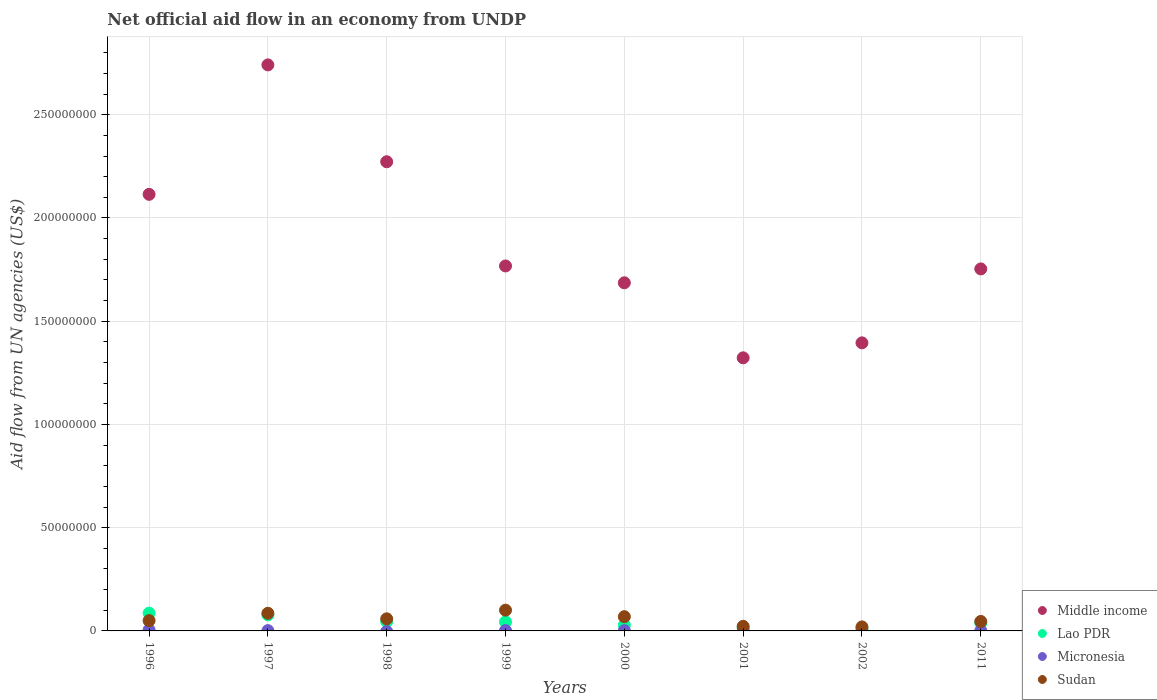Is the number of dotlines equal to the number of legend labels?
Offer a terse response. No. What is the net official aid flow in Lao PDR in 1998?
Give a very brief answer. 4.53e+06. Across all years, what is the maximum net official aid flow in Lao PDR?
Give a very brief answer. 8.61e+06. Across all years, what is the minimum net official aid flow in Middle income?
Your response must be concise. 1.32e+08. What is the total net official aid flow in Lao PDR in the graph?
Give a very brief answer. 3.46e+07. What is the difference between the net official aid flow in Sudan in 1996 and that in 1999?
Provide a short and direct response. -5.05e+06. What is the difference between the net official aid flow in Middle income in 2000 and the net official aid flow in Micronesia in 1996?
Your response must be concise. 1.68e+08. What is the average net official aid flow in Middle income per year?
Make the answer very short. 1.88e+08. In the year 2000, what is the difference between the net official aid flow in Lao PDR and net official aid flow in Middle income?
Your answer should be very brief. -1.66e+08. In how many years, is the net official aid flow in Micronesia greater than 270000000 US$?
Provide a short and direct response. 0. What is the ratio of the net official aid flow in Lao PDR in 2000 to that in 2002?
Make the answer very short. 2.5. What is the difference between the highest and the second highest net official aid flow in Middle income?
Your response must be concise. 4.69e+07. What is the difference between the highest and the lowest net official aid flow in Middle income?
Offer a terse response. 1.42e+08. In how many years, is the net official aid flow in Middle income greater than the average net official aid flow in Middle income taken over all years?
Ensure brevity in your answer.  3. Is it the case that in every year, the sum of the net official aid flow in Middle income and net official aid flow in Lao PDR  is greater than the sum of net official aid flow in Micronesia and net official aid flow in Sudan?
Give a very brief answer. No. Does the net official aid flow in Middle income monotonically increase over the years?
Your answer should be very brief. No. Is the net official aid flow in Middle income strictly greater than the net official aid flow in Micronesia over the years?
Your answer should be very brief. Yes. How many years are there in the graph?
Give a very brief answer. 8. Are the values on the major ticks of Y-axis written in scientific E-notation?
Offer a very short reply. No. Where does the legend appear in the graph?
Keep it short and to the point. Bottom right. How many legend labels are there?
Ensure brevity in your answer.  4. What is the title of the graph?
Your answer should be very brief. Net official aid flow in an economy from UNDP. What is the label or title of the X-axis?
Make the answer very short. Years. What is the label or title of the Y-axis?
Ensure brevity in your answer.  Aid flow from UN agencies (US$). What is the Aid flow from UN agencies (US$) of Middle income in 1996?
Keep it short and to the point. 2.11e+08. What is the Aid flow from UN agencies (US$) of Lao PDR in 1996?
Provide a short and direct response. 8.61e+06. What is the Aid flow from UN agencies (US$) of Micronesia in 1996?
Offer a terse response. 5.10e+05. What is the Aid flow from UN agencies (US$) of Middle income in 1997?
Offer a terse response. 2.74e+08. What is the Aid flow from UN agencies (US$) in Lao PDR in 1997?
Keep it short and to the point. 7.79e+06. What is the Aid flow from UN agencies (US$) in Micronesia in 1997?
Offer a terse response. 1.40e+05. What is the Aid flow from UN agencies (US$) of Sudan in 1997?
Keep it short and to the point. 8.54e+06. What is the Aid flow from UN agencies (US$) of Middle income in 1998?
Offer a terse response. 2.27e+08. What is the Aid flow from UN agencies (US$) in Lao PDR in 1998?
Provide a short and direct response. 4.53e+06. What is the Aid flow from UN agencies (US$) in Sudan in 1998?
Provide a succinct answer. 5.86e+06. What is the Aid flow from UN agencies (US$) of Middle income in 1999?
Your response must be concise. 1.77e+08. What is the Aid flow from UN agencies (US$) of Lao PDR in 1999?
Your response must be concise. 4.37e+06. What is the Aid flow from UN agencies (US$) in Sudan in 1999?
Offer a terse response. 1.00e+07. What is the Aid flow from UN agencies (US$) in Middle income in 2000?
Your answer should be very brief. 1.69e+08. What is the Aid flow from UN agencies (US$) in Lao PDR in 2000?
Offer a terse response. 2.80e+06. What is the Aid flow from UN agencies (US$) of Micronesia in 2000?
Ensure brevity in your answer.  1.50e+05. What is the Aid flow from UN agencies (US$) of Sudan in 2000?
Give a very brief answer. 6.90e+06. What is the Aid flow from UN agencies (US$) in Middle income in 2001?
Give a very brief answer. 1.32e+08. What is the Aid flow from UN agencies (US$) in Lao PDR in 2001?
Make the answer very short. 1.52e+06. What is the Aid flow from UN agencies (US$) of Micronesia in 2001?
Give a very brief answer. 10000. What is the Aid flow from UN agencies (US$) in Sudan in 2001?
Make the answer very short. 2.22e+06. What is the Aid flow from UN agencies (US$) of Middle income in 2002?
Your response must be concise. 1.40e+08. What is the Aid flow from UN agencies (US$) of Lao PDR in 2002?
Your response must be concise. 1.12e+06. What is the Aid flow from UN agencies (US$) of Micronesia in 2002?
Give a very brief answer. 2.00e+04. What is the Aid flow from UN agencies (US$) in Sudan in 2002?
Ensure brevity in your answer.  1.95e+06. What is the Aid flow from UN agencies (US$) in Middle income in 2011?
Your answer should be very brief. 1.75e+08. What is the Aid flow from UN agencies (US$) of Lao PDR in 2011?
Your answer should be very brief. 3.84e+06. What is the Aid flow from UN agencies (US$) of Micronesia in 2011?
Ensure brevity in your answer.  8.00e+04. What is the Aid flow from UN agencies (US$) in Sudan in 2011?
Your answer should be compact. 4.59e+06. Across all years, what is the maximum Aid flow from UN agencies (US$) in Middle income?
Ensure brevity in your answer.  2.74e+08. Across all years, what is the maximum Aid flow from UN agencies (US$) in Lao PDR?
Make the answer very short. 8.61e+06. Across all years, what is the maximum Aid flow from UN agencies (US$) of Micronesia?
Your answer should be very brief. 5.10e+05. Across all years, what is the maximum Aid flow from UN agencies (US$) in Sudan?
Keep it short and to the point. 1.00e+07. Across all years, what is the minimum Aid flow from UN agencies (US$) of Middle income?
Give a very brief answer. 1.32e+08. Across all years, what is the minimum Aid flow from UN agencies (US$) of Lao PDR?
Keep it short and to the point. 1.12e+06. Across all years, what is the minimum Aid flow from UN agencies (US$) of Sudan?
Offer a terse response. 1.95e+06. What is the total Aid flow from UN agencies (US$) of Middle income in the graph?
Your answer should be very brief. 1.51e+09. What is the total Aid flow from UN agencies (US$) in Lao PDR in the graph?
Keep it short and to the point. 3.46e+07. What is the total Aid flow from UN agencies (US$) in Micronesia in the graph?
Offer a terse response. 1.09e+06. What is the total Aid flow from UN agencies (US$) in Sudan in the graph?
Ensure brevity in your answer.  4.51e+07. What is the difference between the Aid flow from UN agencies (US$) of Middle income in 1996 and that in 1997?
Keep it short and to the point. -6.27e+07. What is the difference between the Aid flow from UN agencies (US$) of Lao PDR in 1996 and that in 1997?
Provide a short and direct response. 8.20e+05. What is the difference between the Aid flow from UN agencies (US$) of Sudan in 1996 and that in 1997?
Your answer should be very brief. -3.54e+06. What is the difference between the Aid flow from UN agencies (US$) of Middle income in 1996 and that in 1998?
Ensure brevity in your answer.  -1.58e+07. What is the difference between the Aid flow from UN agencies (US$) in Lao PDR in 1996 and that in 1998?
Keep it short and to the point. 4.08e+06. What is the difference between the Aid flow from UN agencies (US$) in Sudan in 1996 and that in 1998?
Offer a very short reply. -8.60e+05. What is the difference between the Aid flow from UN agencies (US$) in Middle income in 1996 and that in 1999?
Give a very brief answer. 3.47e+07. What is the difference between the Aid flow from UN agencies (US$) of Lao PDR in 1996 and that in 1999?
Offer a very short reply. 4.24e+06. What is the difference between the Aid flow from UN agencies (US$) of Micronesia in 1996 and that in 1999?
Your answer should be compact. 3.30e+05. What is the difference between the Aid flow from UN agencies (US$) of Sudan in 1996 and that in 1999?
Provide a succinct answer. -5.05e+06. What is the difference between the Aid flow from UN agencies (US$) of Middle income in 1996 and that in 2000?
Give a very brief answer. 4.28e+07. What is the difference between the Aid flow from UN agencies (US$) of Lao PDR in 1996 and that in 2000?
Your response must be concise. 5.81e+06. What is the difference between the Aid flow from UN agencies (US$) in Micronesia in 1996 and that in 2000?
Your answer should be very brief. 3.60e+05. What is the difference between the Aid flow from UN agencies (US$) in Sudan in 1996 and that in 2000?
Your response must be concise. -1.90e+06. What is the difference between the Aid flow from UN agencies (US$) in Middle income in 1996 and that in 2001?
Your response must be concise. 7.92e+07. What is the difference between the Aid flow from UN agencies (US$) of Lao PDR in 1996 and that in 2001?
Your answer should be very brief. 7.09e+06. What is the difference between the Aid flow from UN agencies (US$) in Micronesia in 1996 and that in 2001?
Provide a succinct answer. 5.00e+05. What is the difference between the Aid flow from UN agencies (US$) in Sudan in 1996 and that in 2001?
Your answer should be compact. 2.78e+06. What is the difference between the Aid flow from UN agencies (US$) in Middle income in 1996 and that in 2002?
Offer a very short reply. 7.19e+07. What is the difference between the Aid flow from UN agencies (US$) of Lao PDR in 1996 and that in 2002?
Your answer should be very brief. 7.49e+06. What is the difference between the Aid flow from UN agencies (US$) in Micronesia in 1996 and that in 2002?
Your answer should be very brief. 4.90e+05. What is the difference between the Aid flow from UN agencies (US$) in Sudan in 1996 and that in 2002?
Make the answer very short. 3.05e+06. What is the difference between the Aid flow from UN agencies (US$) of Middle income in 1996 and that in 2011?
Provide a short and direct response. 3.61e+07. What is the difference between the Aid flow from UN agencies (US$) in Lao PDR in 1996 and that in 2011?
Give a very brief answer. 4.77e+06. What is the difference between the Aid flow from UN agencies (US$) of Middle income in 1997 and that in 1998?
Make the answer very short. 4.69e+07. What is the difference between the Aid flow from UN agencies (US$) in Lao PDR in 1997 and that in 1998?
Your response must be concise. 3.26e+06. What is the difference between the Aid flow from UN agencies (US$) of Sudan in 1997 and that in 1998?
Provide a succinct answer. 2.68e+06. What is the difference between the Aid flow from UN agencies (US$) in Middle income in 1997 and that in 1999?
Give a very brief answer. 9.74e+07. What is the difference between the Aid flow from UN agencies (US$) in Lao PDR in 1997 and that in 1999?
Offer a terse response. 3.42e+06. What is the difference between the Aid flow from UN agencies (US$) of Sudan in 1997 and that in 1999?
Provide a succinct answer. -1.51e+06. What is the difference between the Aid flow from UN agencies (US$) of Middle income in 1997 and that in 2000?
Offer a terse response. 1.06e+08. What is the difference between the Aid flow from UN agencies (US$) in Lao PDR in 1997 and that in 2000?
Ensure brevity in your answer.  4.99e+06. What is the difference between the Aid flow from UN agencies (US$) in Micronesia in 1997 and that in 2000?
Offer a terse response. -10000. What is the difference between the Aid flow from UN agencies (US$) in Sudan in 1997 and that in 2000?
Keep it short and to the point. 1.64e+06. What is the difference between the Aid flow from UN agencies (US$) in Middle income in 1997 and that in 2001?
Offer a very short reply. 1.42e+08. What is the difference between the Aid flow from UN agencies (US$) in Lao PDR in 1997 and that in 2001?
Your answer should be compact. 6.27e+06. What is the difference between the Aid flow from UN agencies (US$) of Sudan in 1997 and that in 2001?
Ensure brevity in your answer.  6.32e+06. What is the difference between the Aid flow from UN agencies (US$) in Middle income in 1997 and that in 2002?
Keep it short and to the point. 1.35e+08. What is the difference between the Aid flow from UN agencies (US$) of Lao PDR in 1997 and that in 2002?
Ensure brevity in your answer.  6.67e+06. What is the difference between the Aid flow from UN agencies (US$) in Sudan in 1997 and that in 2002?
Your answer should be compact. 6.59e+06. What is the difference between the Aid flow from UN agencies (US$) of Middle income in 1997 and that in 2011?
Your answer should be compact. 9.88e+07. What is the difference between the Aid flow from UN agencies (US$) in Lao PDR in 1997 and that in 2011?
Ensure brevity in your answer.  3.95e+06. What is the difference between the Aid flow from UN agencies (US$) in Micronesia in 1997 and that in 2011?
Your response must be concise. 6.00e+04. What is the difference between the Aid flow from UN agencies (US$) in Sudan in 1997 and that in 2011?
Offer a terse response. 3.95e+06. What is the difference between the Aid flow from UN agencies (US$) in Middle income in 1998 and that in 1999?
Offer a terse response. 5.05e+07. What is the difference between the Aid flow from UN agencies (US$) of Sudan in 1998 and that in 1999?
Provide a short and direct response. -4.19e+06. What is the difference between the Aid flow from UN agencies (US$) in Middle income in 1998 and that in 2000?
Make the answer very short. 5.86e+07. What is the difference between the Aid flow from UN agencies (US$) of Lao PDR in 1998 and that in 2000?
Make the answer very short. 1.73e+06. What is the difference between the Aid flow from UN agencies (US$) in Sudan in 1998 and that in 2000?
Your answer should be compact. -1.04e+06. What is the difference between the Aid flow from UN agencies (US$) in Middle income in 1998 and that in 2001?
Provide a succinct answer. 9.50e+07. What is the difference between the Aid flow from UN agencies (US$) in Lao PDR in 1998 and that in 2001?
Your answer should be compact. 3.01e+06. What is the difference between the Aid flow from UN agencies (US$) of Sudan in 1998 and that in 2001?
Offer a terse response. 3.64e+06. What is the difference between the Aid flow from UN agencies (US$) in Middle income in 1998 and that in 2002?
Offer a terse response. 8.77e+07. What is the difference between the Aid flow from UN agencies (US$) in Lao PDR in 1998 and that in 2002?
Give a very brief answer. 3.41e+06. What is the difference between the Aid flow from UN agencies (US$) in Sudan in 1998 and that in 2002?
Your response must be concise. 3.91e+06. What is the difference between the Aid flow from UN agencies (US$) in Middle income in 1998 and that in 2011?
Your response must be concise. 5.19e+07. What is the difference between the Aid flow from UN agencies (US$) of Lao PDR in 1998 and that in 2011?
Offer a terse response. 6.90e+05. What is the difference between the Aid flow from UN agencies (US$) in Sudan in 1998 and that in 2011?
Provide a succinct answer. 1.27e+06. What is the difference between the Aid flow from UN agencies (US$) of Middle income in 1999 and that in 2000?
Make the answer very short. 8.16e+06. What is the difference between the Aid flow from UN agencies (US$) of Lao PDR in 1999 and that in 2000?
Ensure brevity in your answer.  1.57e+06. What is the difference between the Aid flow from UN agencies (US$) of Micronesia in 1999 and that in 2000?
Ensure brevity in your answer.  3.00e+04. What is the difference between the Aid flow from UN agencies (US$) in Sudan in 1999 and that in 2000?
Ensure brevity in your answer.  3.15e+06. What is the difference between the Aid flow from UN agencies (US$) of Middle income in 1999 and that in 2001?
Your answer should be very brief. 4.45e+07. What is the difference between the Aid flow from UN agencies (US$) in Lao PDR in 1999 and that in 2001?
Provide a short and direct response. 2.85e+06. What is the difference between the Aid flow from UN agencies (US$) in Micronesia in 1999 and that in 2001?
Provide a short and direct response. 1.70e+05. What is the difference between the Aid flow from UN agencies (US$) in Sudan in 1999 and that in 2001?
Offer a terse response. 7.83e+06. What is the difference between the Aid flow from UN agencies (US$) in Middle income in 1999 and that in 2002?
Your answer should be compact. 3.72e+07. What is the difference between the Aid flow from UN agencies (US$) of Lao PDR in 1999 and that in 2002?
Your answer should be very brief. 3.25e+06. What is the difference between the Aid flow from UN agencies (US$) in Micronesia in 1999 and that in 2002?
Provide a succinct answer. 1.60e+05. What is the difference between the Aid flow from UN agencies (US$) in Sudan in 1999 and that in 2002?
Ensure brevity in your answer.  8.10e+06. What is the difference between the Aid flow from UN agencies (US$) of Middle income in 1999 and that in 2011?
Provide a succinct answer. 1.43e+06. What is the difference between the Aid flow from UN agencies (US$) in Lao PDR in 1999 and that in 2011?
Offer a very short reply. 5.30e+05. What is the difference between the Aid flow from UN agencies (US$) in Sudan in 1999 and that in 2011?
Provide a succinct answer. 5.46e+06. What is the difference between the Aid flow from UN agencies (US$) of Middle income in 2000 and that in 2001?
Offer a very short reply. 3.63e+07. What is the difference between the Aid flow from UN agencies (US$) in Lao PDR in 2000 and that in 2001?
Your answer should be very brief. 1.28e+06. What is the difference between the Aid flow from UN agencies (US$) of Sudan in 2000 and that in 2001?
Keep it short and to the point. 4.68e+06. What is the difference between the Aid flow from UN agencies (US$) in Middle income in 2000 and that in 2002?
Offer a terse response. 2.91e+07. What is the difference between the Aid flow from UN agencies (US$) of Lao PDR in 2000 and that in 2002?
Provide a short and direct response. 1.68e+06. What is the difference between the Aid flow from UN agencies (US$) of Micronesia in 2000 and that in 2002?
Provide a succinct answer. 1.30e+05. What is the difference between the Aid flow from UN agencies (US$) of Sudan in 2000 and that in 2002?
Provide a succinct answer. 4.95e+06. What is the difference between the Aid flow from UN agencies (US$) of Middle income in 2000 and that in 2011?
Offer a very short reply. -6.73e+06. What is the difference between the Aid flow from UN agencies (US$) in Lao PDR in 2000 and that in 2011?
Ensure brevity in your answer.  -1.04e+06. What is the difference between the Aid flow from UN agencies (US$) of Sudan in 2000 and that in 2011?
Give a very brief answer. 2.31e+06. What is the difference between the Aid flow from UN agencies (US$) of Middle income in 2001 and that in 2002?
Give a very brief answer. -7.25e+06. What is the difference between the Aid flow from UN agencies (US$) of Lao PDR in 2001 and that in 2002?
Your answer should be compact. 4.00e+05. What is the difference between the Aid flow from UN agencies (US$) in Middle income in 2001 and that in 2011?
Your response must be concise. -4.31e+07. What is the difference between the Aid flow from UN agencies (US$) in Lao PDR in 2001 and that in 2011?
Ensure brevity in your answer.  -2.32e+06. What is the difference between the Aid flow from UN agencies (US$) of Micronesia in 2001 and that in 2011?
Your answer should be compact. -7.00e+04. What is the difference between the Aid flow from UN agencies (US$) of Sudan in 2001 and that in 2011?
Keep it short and to the point. -2.37e+06. What is the difference between the Aid flow from UN agencies (US$) in Middle income in 2002 and that in 2011?
Ensure brevity in your answer.  -3.58e+07. What is the difference between the Aid flow from UN agencies (US$) of Lao PDR in 2002 and that in 2011?
Give a very brief answer. -2.72e+06. What is the difference between the Aid flow from UN agencies (US$) in Sudan in 2002 and that in 2011?
Offer a very short reply. -2.64e+06. What is the difference between the Aid flow from UN agencies (US$) of Middle income in 1996 and the Aid flow from UN agencies (US$) of Lao PDR in 1997?
Offer a very short reply. 2.04e+08. What is the difference between the Aid flow from UN agencies (US$) in Middle income in 1996 and the Aid flow from UN agencies (US$) in Micronesia in 1997?
Your answer should be compact. 2.11e+08. What is the difference between the Aid flow from UN agencies (US$) of Middle income in 1996 and the Aid flow from UN agencies (US$) of Sudan in 1997?
Your response must be concise. 2.03e+08. What is the difference between the Aid flow from UN agencies (US$) in Lao PDR in 1996 and the Aid flow from UN agencies (US$) in Micronesia in 1997?
Give a very brief answer. 8.47e+06. What is the difference between the Aid flow from UN agencies (US$) in Micronesia in 1996 and the Aid flow from UN agencies (US$) in Sudan in 1997?
Offer a terse response. -8.03e+06. What is the difference between the Aid flow from UN agencies (US$) in Middle income in 1996 and the Aid flow from UN agencies (US$) in Lao PDR in 1998?
Ensure brevity in your answer.  2.07e+08. What is the difference between the Aid flow from UN agencies (US$) of Middle income in 1996 and the Aid flow from UN agencies (US$) of Sudan in 1998?
Your answer should be very brief. 2.06e+08. What is the difference between the Aid flow from UN agencies (US$) of Lao PDR in 1996 and the Aid flow from UN agencies (US$) of Sudan in 1998?
Keep it short and to the point. 2.75e+06. What is the difference between the Aid flow from UN agencies (US$) in Micronesia in 1996 and the Aid flow from UN agencies (US$) in Sudan in 1998?
Your response must be concise. -5.35e+06. What is the difference between the Aid flow from UN agencies (US$) of Middle income in 1996 and the Aid flow from UN agencies (US$) of Lao PDR in 1999?
Keep it short and to the point. 2.07e+08. What is the difference between the Aid flow from UN agencies (US$) of Middle income in 1996 and the Aid flow from UN agencies (US$) of Micronesia in 1999?
Your response must be concise. 2.11e+08. What is the difference between the Aid flow from UN agencies (US$) in Middle income in 1996 and the Aid flow from UN agencies (US$) in Sudan in 1999?
Your answer should be very brief. 2.01e+08. What is the difference between the Aid flow from UN agencies (US$) in Lao PDR in 1996 and the Aid flow from UN agencies (US$) in Micronesia in 1999?
Make the answer very short. 8.43e+06. What is the difference between the Aid flow from UN agencies (US$) of Lao PDR in 1996 and the Aid flow from UN agencies (US$) of Sudan in 1999?
Your answer should be compact. -1.44e+06. What is the difference between the Aid flow from UN agencies (US$) in Micronesia in 1996 and the Aid flow from UN agencies (US$) in Sudan in 1999?
Make the answer very short. -9.54e+06. What is the difference between the Aid flow from UN agencies (US$) of Middle income in 1996 and the Aid flow from UN agencies (US$) of Lao PDR in 2000?
Your answer should be very brief. 2.09e+08. What is the difference between the Aid flow from UN agencies (US$) of Middle income in 1996 and the Aid flow from UN agencies (US$) of Micronesia in 2000?
Your response must be concise. 2.11e+08. What is the difference between the Aid flow from UN agencies (US$) of Middle income in 1996 and the Aid flow from UN agencies (US$) of Sudan in 2000?
Offer a very short reply. 2.05e+08. What is the difference between the Aid flow from UN agencies (US$) in Lao PDR in 1996 and the Aid flow from UN agencies (US$) in Micronesia in 2000?
Offer a very short reply. 8.46e+06. What is the difference between the Aid flow from UN agencies (US$) of Lao PDR in 1996 and the Aid flow from UN agencies (US$) of Sudan in 2000?
Provide a succinct answer. 1.71e+06. What is the difference between the Aid flow from UN agencies (US$) of Micronesia in 1996 and the Aid flow from UN agencies (US$) of Sudan in 2000?
Offer a very short reply. -6.39e+06. What is the difference between the Aid flow from UN agencies (US$) in Middle income in 1996 and the Aid flow from UN agencies (US$) in Lao PDR in 2001?
Provide a short and direct response. 2.10e+08. What is the difference between the Aid flow from UN agencies (US$) in Middle income in 1996 and the Aid flow from UN agencies (US$) in Micronesia in 2001?
Your answer should be very brief. 2.11e+08. What is the difference between the Aid flow from UN agencies (US$) in Middle income in 1996 and the Aid flow from UN agencies (US$) in Sudan in 2001?
Give a very brief answer. 2.09e+08. What is the difference between the Aid flow from UN agencies (US$) of Lao PDR in 1996 and the Aid flow from UN agencies (US$) of Micronesia in 2001?
Provide a short and direct response. 8.60e+06. What is the difference between the Aid flow from UN agencies (US$) of Lao PDR in 1996 and the Aid flow from UN agencies (US$) of Sudan in 2001?
Your answer should be compact. 6.39e+06. What is the difference between the Aid flow from UN agencies (US$) of Micronesia in 1996 and the Aid flow from UN agencies (US$) of Sudan in 2001?
Your answer should be very brief. -1.71e+06. What is the difference between the Aid flow from UN agencies (US$) in Middle income in 1996 and the Aid flow from UN agencies (US$) in Lao PDR in 2002?
Your response must be concise. 2.10e+08. What is the difference between the Aid flow from UN agencies (US$) of Middle income in 1996 and the Aid flow from UN agencies (US$) of Micronesia in 2002?
Ensure brevity in your answer.  2.11e+08. What is the difference between the Aid flow from UN agencies (US$) in Middle income in 1996 and the Aid flow from UN agencies (US$) in Sudan in 2002?
Ensure brevity in your answer.  2.09e+08. What is the difference between the Aid flow from UN agencies (US$) of Lao PDR in 1996 and the Aid flow from UN agencies (US$) of Micronesia in 2002?
Offer a terse response. 8.59e+06. What is the difference between the Aid flow from UN agencies (US$) in Lao PDR in 1996 and the Aid flow from UN agencies (US$) in Sudan in 2002?
Your answer should be very brief. 6.66e+06. What is the difference between the Aid flow from UN agencies (US$) of Micronesia in 1996 and the Aid flow from UN agencies (US$) of Sudan in 2002?
Offer a very short reply. -1.44e+06. What is the difference between the Aid flow from UN agencies (US$) in Middle income in 1996 and the Aid flow from UN agencies (US$) in Lao PDR in 2011?
Make the answer very short. 2.08e+08. What is the difference between the Aid flow from UN agencies (US$) in Middle income in 1996 and the Aid flow from UN agencies (US$) in Micronesia in 2011?
Offer a terse response. 2.11e+08. What is the difference between the Aid flow from UN agencies (US$) in Middle income in 1996 and the Aid flow from UN agencies (US$) in Sudan in 2011?
Make the answer very short. 2.07e+08. What is the difference between the Aid flow from UN agencies (US$) in Lao PDR in 1996 and the Aid flow from UN agencies (US$) in Micronesia in 2011?
Your answer should be compact. 8.53e+06. What is the difference between the Aid flow from UN agencies (US$) of Lao PDR in 1996 and the Aid flow from UN agencies (US$) of Sudan in 2011?
Offer a very short reply. 4.02e+06. What is the difference between the Aid flow from UN agencies (US$) of Micronesia in 1996 and the Aid flow from UN agencies (US$) of Sudan in 2011?
Your answer should be very brief. -4.08e+06. What is the difference between the Aid flow from UN agencies (US$) of Middle income in 1997 and the Aid flow from UN agencies (US$) of Lao PDR in 1998?
Make the answer very short. 2.70e+08. What is the difference between the Aid flow from UN agencies (US$) in Middle income in 1997 and the Aid flow from UN agencies (US$) in Sudan in 1998?
Your answer should be very brief. 2.68e+08. What is the difference between the Aid flow from UN agencies (US$) in Lao PDR in 1997 and the Aid flow from UN agencies (US$) in Sudan in 1998?
Your answer should be compact. 1.93e+06. What is the difference between the Aid flow from UN agencies (US$) in Micronesia in 1997 and the Aid flow from UN agencies (US$) in Sudan in 1998?
Your answer should be very brief. -5.72e+06. What is the difference between the Aid flow from UN agencies (US$) of Middle income in 1997 and the Aid flow from UN agencies (US$) of Lao PDR in 1999?
Provide a succinct answer. 2.70e+08. What is the difference between the Aid flow from UN agencies (US$) in Middle income in 1997 and the Aid flow from UN agencies (US$) in Micronesia in 1999?
Provide a succinct answer. 2.74e+08. What is the difference between the Aid flow from UN agencies (US$) in Middle income in 1997 and the Aid flow from UN agencies (US$) in Sudan in 1999?
Keep it short and to the point. 2.64e+08. What is the difference between the Aid flow from UN agencies (US$) of Lao PDR in 1997 and the Aid flow from UN agencies (US$) of Micronesia in 1999?
Provide a short and direct response. 7.61e+06. What is the difference between the Aid flow from UN agencies (US$) in Lao PDR in 1997 and the Aid flow from UN agencies (US$) in Sudan in 1999?
Give a very brief answer. -2.26e+06. What is the difference between the Aid flow from UN agencies (US$) in Micronesia in 1997 and the Aid flow from UN agencies (US$) in Sudan in 1999?
Make the answer very short. -9.91e+06. What is the difference between the Aid flow from UN agencies (US$) in Middle income in 1997 and the Aid flow from UN agencies (US$) in Lao PDR in 2000?
Provide a short and direct response. 2.71e+08. What is the difference between the Aid flow from UN agencies (US$) of Middle income in 1997 and the Aid flow from UN agencies (US$) of Micronesia in 2000?
Offer a very short reply. 2.74e+08. What is the difference between the Aid flow from UN agencies (US$) of Middle income in 1997 and the Aid flow from UN agencies (US$) of Sudan in 2000?
Offer a terse response. 2.67e+08. What is the difference between the Aid flow from UN agencies (US$) of Lao PDR in 1997 and the Aid flow from UN agencies (US$) of Micronesia in 2000?
Ensure brevity in your answer.  7.64e+06. What is the difference between the Aid flow from UN agencies (US$) of Lao PDR in 1997 and the Aid flow from UN agencies (US$) of Sudan in 2000?
Keep it short and to the point. 8.90e+05. What is the difference between the Aid flow from UN agencies (US$) of Micronesia in 1997 and the Aid flow from UN agencies (US$) of Sudan in 2000?
Offer a very short reply. -6.76e+06. What is the difference between the Aid flow from UN agencies (US$) in Middle income in 1997 and the Aid flow from UN agencies (US$) in Lao PDR in 2001?
Provide a short and direct response. 2.73e+08. What is the difference between the Aid flow from UN agencies (US$) of Middle income in 1997 and the Aid flow from UN agencies (US$) of Micronesia in 2001?
Offer a very short reply. 2.74e+08. What is the difference between the Aid flow from UN agencies (US$) of Middle income in 1997 and the Aid flow from UN agencies (US$) of Sudan in 2001?
Provide a succinct answer. 2.72e+08. What is the difference between the Aid flow from UN agencies (US$) in Lao PDR in 1997 and the Aid flow from UN agencies (US$) in Micronesia in 2001?
Keep it short and to the point. 7.78e+06. What is the difference between the Aid flow from UN agencies (US$) in Lao PDR in 1997 and the Aid flow from UN agencies (US$) in Sudan in 2001?
Provide a succinct answer. 5.57e+06. What is the difference between the Aid flow from UN agencies (US$) in Micronesia in 1997 and the Aid flow from UN agencies (US$) in Sudan in 2001?
Provide a succinct answer. -2.08e+06. What is the difference between the Aid flow from UN agencies (US$) in Middle income in 1997 and the Aid flow from UN agencies (US$) in Lao PDR in 2002?
Keep it short and to the point. 2.73e+08. What is the difference between the Aid flow from UN agencies (US$) of Middle income in 1997 and the Aid flow from UN agencies (US$) of Micronesia in 2002?
Keep it short and to the point. 2.74e+08. What is the difference between the Aid flow from UN agencies (US$) in Middle income in 1997 and the Aid flow from UN agencies (US$) in Sudan in 2002?
Your response must be concise. 2.72e+08. What is the difference between the Aid flow from UN agencies (US$) in Lao PDR in 1997 and the Aid flow from UN agencies (US$) in Micronesia in 2002?
Your answer should be very brief. 7.77e+06. What is the difference between the Aid flow from UN agencies (US$) of Lao PDR in 1997 and the Aid flow from UN agencies (US$) of Sudan in 2002?
Offer a terse response. 5.84e+06. What is the difference between the Aid flow from UN agencies (US$) of Micronesia in 1997 and the Aid flow from UN agencies (US$) of Sudan in 2002?
Your answer should be very brief. -1.81e+06. What is the difference between the Aid flow from UN agencies (US$) of Middle income in 1997 and the Aid flow from UN agencies (US$) of Lao PDR in 2011?
Ensure brevity in your answer.  2.70e+08. What is the difference between the Aid flow from UN agencies (US$) of Middle income in 1997 and the Aid flow from UN agencies (US$) of Micronesia in 2011?
Ensure brevity in your answer.  2.74e+08. What is the difference between the Aid flow from UN agencies (US$) of Middle income in 1997 and the Aid flow from UN agencies (US$) of Sudan in 2011?
Give a very brief answer. 2.70e+08. What is the difference between the Aid flow from UN agencies (US$) in Lao PDR in 1997 and the Aid flow from UN agencies (US$) in Micronesia in 2011?
Offer a terse response. 7.71e+06. What is the difference between the Aid flow from UN agencies (US$) of Lao PDR in 1997 and the Aid flow from UN agencies (US$) of Sudan in 2011?
Offer a terse response. 3.20e+06. What is the difference between the Aid flow from UN agencies (US$) in Micronesia in 1997 and the Aid flow from UN agencies (US$) in Sudan in 2011?
Your answer should be very brief. -4.45e+06. What is the difference between the Aid flow from UN agencies (US$) in Middle income in 1998 and the Aid flow from UN agencies (US$) in Lao PDR in 1999?
Offer a terse response. 2.23e+08. What is the difference between the Aid flow from UN agencies (US$) in Middle income in 1998 and the Aid flow from UN agencies (US$) in Micronesia in 1999?
Your answer should be very brief. 2.27e+08. What is the difference between the Aid flow from UN agencies (US$) in Middle income in 1998 and the Aid flow from UN agencies (US$) in Sudan in 1999?
Ensure brevity in your answer.  2.17e+08. What is the difference between the Aid flow from UN agencies (US$) in Lao PDR in 1998 and the Aid flow from UN agencies (US$) in Micronesia in 1999?
Your answer should be very brief. 4.35e+06. What is the difference between the Aid flow from UN agencies (US$) of Lao PDR in 1998 and the Aid flow from UN agencies (US$) of Sudan in 1999?
Provide a succinct answer. -5.52e+06. What is the difference between the Aid flow from UN agencies (US$) of Middle income in 1998 and the Aid flow from UN agencies (US$) of Lao PDR in 2000?
Provide a short and direct response. 2.24e+08. What is the difference between the Aid flow from UN agencies (US$) of Middle income in 1998 and the Aid flow from UN agencies (US$) of Micronesia in 2000?
Ensure brevity in your answer.  2.27e+08. What is the difference between the Aid flow from UN agencies (US$) in Middle income in 1998 and the Aid flow from UN agencies (US$) in Sudan in 2000?
Your answer should be compact. 2.20e+08. What is the difference between the Aid flow from UN agencies (US$) in Lao PDR in 1998 and the Aid flow from UN agencies (US$) in Micronesia in 2000?
Offer a very short reply. 4.38e+06. What is the difference between the Aid flow from UN agencies (US$) in Lao PDR in 1998 and the Aid flow from UN agencies (US$) in Sudan in 2000?
Provide a short and direct response. -2.37e+06. What is the difference between the Aid flow from UN agencies (US$) of Middle income in 1998 and the Aid flow from UN agencies (US$) of Lao PDR in 2001?
Your response must be concise. 2.26e+08. What is the difference between the Aid flow from UN agencies (US$) of Middle income in 1998 and the Aid flow from UN agencies (US$) of Micronesia in 2001?
Provide a succinct answer. 2.27e+08. What is the difference between the Aid flow from UN agencies (US$) of Middle income in 1998 and the Aid flow from UN agencies (US$) of Sudan in 2001?
Give a very brief answer. 2.25e+08. What is the difference between the Aid flow from UN agencies (US$) in Lao PDR in 1998 and the Aid flow from UN agencies (US$) in Micronesia in 2001?
Your answer should be compact. 4.52e+06. What is the difference between the Aid flow from UN agencies (US$) in Lao PDR in 1998 and the Aid flow from UN agencies (US$) in Sudan in 2001?
Your response must be concise. 2.31e+06. What is the difference between the Aid flow from UN agencies (US$) of Middle income in 1998 and the Aid flow from UN agencies (US$) of Lao PDR in 2002?
Provide a short and direct response. 2.26e+08. What is the difference between the Aid flow from UN agencies (US$) of Middle income in 1998 and the Aid flow from UN agencies (US$) of Micronesia in 2002?
Provide a short and direct response. 2.27e+08. What is the difference between the Aid flow from UN agencies (US$) of Middle income in 1998 and the Aid flow from UN agencies (US$) of Sudan in 2002?
Provide a short and direct response. 2.25e+08. What is the difference between the Aid flow from UN agencies (US$) in Lao PDR in 1998 and the Aid flow from UN agencies (US$) in Micronesia in 2002?
Keep it short and to the point. 4.51e+06. What is the difference between the Aid flow from UN agencies (US$) in Lao PDR in 1998 and the Aid flow from UN agencies (US$) in Sudan in 2002?
Offer a very short reply. 2.58e+06. What is the difference between the Aid flow from UN agencies (US$) in Middle income in 1998 and the Aid flow from UN agencies (US$) in Lao PDR in 2011?
Offer a terse response. 2.23e+08. What is the difference between the Aid flow from UN agencies (US$) in Middle income in 1998 and the Aid flow from UN agencies (US$) in Micronesia in 2011?
Your answer should be very brief. 2.27e+08. What is the difference between the Aid flow from UN agencies (US$) of Middle income in 1998 and the Aid flow from UN agencies (US$) of Sudan in 2011?
Keep it short and to the point. 2.23e+08. What is the difference between the Aid flow from UN agencies (US$) of Lao PDR in 1998 and the Aid flow from UN agencies (US$) of Micronesia in 2011?
Offer a very short reply. 4.45e+06. What is the difference between the Aid flow from UN agencies (US$) in Lao PDR in 1998 and the Aid flow from UN agencies (US$) in Sudan in 2011?
Make the answer very short. -6.00e+04. What is the difference between the Aid flow from UN agencies (US$) of Middle income in 1999 and the Aid flow from UN agencies (US$) of Lao PDR in 2000?
Your answer should be very brief. 1.74e+08. What is the difference between the Aid flow from UN agencies (US$) of Middle income in 1999 and the Aid flow from UN agencies (US$) of Micronesia in 2000?
Make the answer very short. 1.77e+08. What is the difference between the Aid flow from UN agencies (US$) of Middle income in 1999 and the Aid flow from UN agencies (US$) of Sudan in 2000?
Provide a succinct answer. 1.70e+08. What is the difference between the Aid flow from UN agencies (US$) of Lao PDR in 1999 and the Aid flow from UN agencies (US$) of Micronesia in 2000?
Your answer should be very brief. 4.22e+06. What is the difference between the Aid flow from UN agencies (US$) of Lao PDR in 1999 and the Aid flow from UN agencies (US$) of Sudan in 2000?
Offer a terse response. -2.53e+06. What is the difference between the Aid flow from UN agencies (US$) in Micronesia in 1999 and the Aid flow from UN agencies (US$) in Sudan in 2000?
Keep it short and to the point. -6.72e+06. What is the difference between the Aid flow from UN agencies (US$) in Middle income in 1999 and the Aid flow from UN agencies (US$) in Lao PDR in 2001?
Your answer should be very brief. 1.75e+08. What is the difference between the Aid flow from UN agencies (US$) of Middle income in 1999 and the Aid flow from UN agencies (US$) of Micronesia in 2001?
Your answer should be compact. 1.77e+08. What is the difference between the Aid flow from UN agencies (US$) of Middle income in 1999 and the Aid flow from UN agencies (US$) of Sudan in 2001?
Your answer should be very brief. 1.75e+08. What is the difference between the Aid flow from UN agencies (US$) of Lao PDR in 1999 and the Aid flow from UN agencies (US$) of Micronesia in 2001?
Provide a succinct answer. 4.36e+06. What is the difference between the Aid flow from UN agencies (US$) in Lao PDR in 1999 and the Aid flow from UN agencies (US$) in Sudan in 2001?
Your answer should be compact. 2.15e+06. What is the difference between the Aid flow from UN agencies (US$) of Micronesia in 1999 and the Aid flow from UN agencies (US$) of Sudan in 2001?
Ensure brevity in your answer.  -2.04e+06. What is the difference between the Aid flow from UN agencies (US$) in Middle income in 1999 and the Aid flow from UN agencies (US$) in Lao PDR in 2002?
Your answer should be very brief. 1.76e+08. What is the difference between the Aid flow from UN agencies (US$) in Middle income in 1999 and the Aid flow from UN agencies (US$) in Micronesia in 2002?
Your answer should be very brief. 1.77e+08. What is the difference between the Aid flow from UN agencies (US$) in Middle income in 1999 and the Aid flow from UN agencies (US$) in Sudan in 2002?
Give a very brief answer. 1.75e+08. What is the difference between the Aid flow from UN agencies (US$) of Lao PDR in 1999 and the Aid flow from UN agencies (US$) of Micronesia in 2002?
Your response must be concise. 4.35e+06. What is the difference between the Aid flow from UN agencies (US$) in Lao PDR in 1999 and the Aid flow from UN agencies (US$) in Sudan in 2002?
Offer a very short reply. 2.42e+06. What is the difference between the Aid flow from UN agencies (US$) in Micronesia in 1999 and the Aid flow from UN agencies (US$) in Sudan in 2002?
Provide a succinct answer. -1.77e+06. What is the difference between the Aid flow from UN agencies (US$) of Middle income in 1999 and the Aid flow from UN agencies (US$) of Lao PDR in 2011?
Provide a short and direct response. 1.73e+08. What is the difference between the Aid flow from UN agencies (US$) of Middle income in 1999 and the Aid flow from UN agencies (US$) of Micronesia in 2011?
Provide a short and direct response. 1.77e+08. What is the difference between the Aid flow from UN agencies (US$) of Middle income in 1999 and the Aid flow from UN agencies (US$) of Sudan in 2011?
Your answer should be very brief. 1.72e+08. What is the difference between the Aid flow from UN agencies (US$) in Lao PDR in 1999 and the Aid flow from UN agencies (US$) in Micronesia in 2011?
Ensure brevity in your answer.  4.29e+06. What is the difference between the Aid flow from UN agencies (US$) of Lao PDR in 1999 and the Aid flow from UN agencies (US$) of Sudan in 2011?
Provide a succinct answer. -2.20e+05. What is the difference between the Aid flow from UN agencies (US$) of Micronesia in 1999 and the Aid flow from UN agencies (US$) of Sudan in 2011?
Provide a short and direct response. -4.41e+06. What is the difference between the Aid flow from UN agencies (US$) of Middle income in 2000 and the Aid flow from UN agencies (US$) of Lao PDR in 2001?
Provide a succinct answer. 1.67e+08. What is the difference between the Aid flow from UN agencies (US$) of Middle income in 2000 and the Aid flow from UN agencies (US$) of Micronesia in 2001?
Provide a short and direct response. 1.69e+08. What is the difference between the Aid flow from UN agencies (US$) in Middle income in 2000 and the Aid flow from UN agencies (US$) in Sudan in 2001?
Provide a succinct answer. 1.66e+08. What is the difference between the Aid flow from UN agencies (US$) of Lao PDR in 2000 and the Aid flow from UN agencies (US$) of Micronesia in 2001?
Your answer should be very brief. 2.79e+06. What is the difference between the Aid flow from UN agencies (US$) of Lao PDR in 2000 and the Aid flow from UN agencies (US$) of Sudan in 2001?
Give a very brief answer. 5.80e+05. What is the difference between the Aid flow from UN agencies (US$) of Micronesia in 2000 and the Aid flow from UN agencies (US$) of Sudan in 2001?
Give a very brief answer. -2.07e+06. What is the difference between the Aid flow from UN agencies (US$) of Middle income in 2000 and the Aid flow from UN agencies (US$) of Lao PDR in 2002?
Offer a very short reply. 1.67e+08. What is the difference between the Aid flow from UN agencies (US$) of Middle income in 2000 and the Aid flow from UN agencies (US$) of Micronesia in 2002?
Offer a very short reply. 1.69e+08. What is the difference between the Aid flow from UN agencies (US$) of Middle income in 2000 and the Aid flow from UN agencies (US$) of Sudan in 2002?
Your answer should be compact. 1.67e+08. What is the difference between the Aid flow from UN agencies (US$) of Lao PDR in 2000 and the Aid flow from UN agencies (US$) of Micronesia in 2002?
Ensure brevity in your answer.  2.78e+06. What is the difference between the Aid flow from UN agencies (US$) in Lao PDR in 2000 and the Aid flow from UN agencies (US$) in Sudan in 2002?
Give a very brief answer. 8.50e+05. What is the difference between the Aid flow from UN agencies (US$) in Micronesia in 2000 and the Aid flow from UN agencies (US$) in Sudan in 2002?
Make the answer very short. -1.80e+06. What is the difference between the Aid flow from UN agencies (US$) in Middle income in 2000 and the Aid flow from UN agencies (US$) in Lao PDR in 2011?
Offer a very short reply. 1.65e+08. What is the difference between the Aid flow from UN agencies (US$) in Middle income in 2000 and the Aid flow from UN agencies (US$) in Micronesia in 2011?
Offer a terse response. 1.69e+08. What is the difference between the Aid flow from UN agencies (US$) of Middle income in 2000 and the Aid flow from UN agencies (US$) of Sudan in 2011?
Make the answer very short. 1.64e+08. What is the difference between the Aid flow from UN agencies (US$) of Lao PDR in 2000 and the Aid flow from UN agencies (US$) of Micronesia in 2011?
Provide a succinct answer. 2.72e+06. What is the difference between the Aid flow from UN agencies (US$) in Lao PDR in 2000 and the Aid flow from UN agencies (US$) in Sudan in 2011?
Give a very brief answer. -1.79e+06. What is the difference between the Aid flow from UN agencies (US$) in Micronesia in 2000 and the Aid flow from UN agencies (US$) in Sudan in 2011?
Provide a short and direct response. -4.44e+06. What is the difference between the Aid flow from UN agencies (US$) of Middle income in 2001 and the Aid flow from UN agencies (US$) of Lao PDR in 2002?
Keep it short and to the point. 1.31e+08. What is the difference between the Aid flow from UN agencies (US$) of Middle income in 2001 and the Aid flow from UN agencies (US$) of Micronesia in 2002?
Keep it short and to the point. 1.32e+08. What is the difference between the Aid flow from UN agencies (US$) in Middle income in 2001 and the Aid flow from UN agencies (US$) in Sudan in 2002?
Give a very brief answer. 1.30e+08. What is the difference between the Aid flow from UN agencies (US$) in Lao PDR in 2001 and the Aid flow from UN agencies (US$) in Micronesia in 2002?
Ensure brevity in your answer.  1.50e+06. What is the difference between the Aid flow from UN agencies (US$) in Lao PDR in 2001 and the Aid flow from UN agencies (US$) in Sudan in 2002?
Offer a terse response. -4.30e+05. What is the difference between the Aid flow from UN agencies (US$) of Micronesia in 2001 and the Aid flow from UN agencies (US$) of Sudan in 2002?
Give a very brief answer. -1.94e+06. What is the difference between the Aid flow from UN agencies (US$) in Middle income in 2001 and the Aid flow from UN agencies (US$) in Lao PDR in 2011?
Keep it short and to the point. 1.28e+08. What is the difference between the Aid flow from UN agencies (US$) of Middle income in 2001 and the Aid flow from UN agencies (US$) of Micronesia in 2011?
Ensure brevity in your answer.  1.32e+08. What is the difference between the Aid flow from UN agencies (US$) of Middle income in 2001 and the Aid flow from UN agencies (US$) of Sudan in 2011?
Make the answer very short. 1.28e+08. What is the difference between the Aid flow from UN agencies (US$) of Lao PDR in 2001 and the Aid flow from UN agencies (US$) of Micronesia in 2011?
Ensure brevity in your answer.  1.44e+06. What is the difference between the Aid flow from UN agencies (US$) of Lao PDR in 2001 and the Aid flow from UN agencies (US$) of Sudan in 2011?
Offer a terse response. -3.07e+06. What is the difference between the Aid flow from UN agencies (US$) in Micronesia in 2001 and the Aid flow from UN agencies (US$) in Sudan in 2011?
Your answer should be compact. -4.58e+06. What is the difference between the Aid flow from UN agencies (US$) of Middle income in 2002 and the Aid flow from UN agencies (US$) of Lao PDR in 2011?
Your answer should be very brief. 1.36e+08. What is the difference between the Aid flow from UN agencies (US$) in Middle income in 2002 and the Aid flow from UN agencies (US$) in Micronesia in 2011?
Give a very brief answer. 1.39e+08. What is the difference between the Aid flow from UN agencies (US$) of Middle income in 2002 and the Aid flow from UN agencies (US$) of Sudan in 2011?
Give a very brief answer. 1.35e+08. What is the difference between the Aid flow from UN agencies (US$) of Lao PDR in 2002 and the Aid flow from UN agencies (US$) of Micronesia in 2011?
Give a very brief answer. 1.04e+06. What is the difference between the Aid flow from UN agencies (US$) of Lao PDR in 2002 and the Aid flow from UN agencies (US$) of Sudan in 2011?
Offer a very short reply. -3.47e+06. What is the difference between the Aid flow from UN agencies (US$) of Micronesia in 2002 and the Aid flow from UN agencies (US$) of Sudan in 2011?
Provide a short and direct response. -4.57e+06. What is the average Aid flow from UN agencies (US$) of Middle income per year?
Ensure brevity in your answer.  1.88e+08. What is the average Aid flow from UN agencies (US$) in Lao PDR per year?
Offer a terse response. 4.32e+06. What is the average Aid flow from UN agencies (US$) in Micronesia per year?
Give a very brief answer. 1.36e+05. What is the average Aid flow from UN agencies (US$) in Sudan per year?
Ensure brevity in your answer.  5.64e+06. In the year 1996, what is the difference between the Aid flow from UN agencies (US$) of Middle income and Aid flow from UN agencies (US$) of Lao PDR?
Your answer should be very brief. 2.03e+08. In the year 1996, what is the difference between the Aid flow from UN agencies (US$) in Middle income and Aid flow from UN agencies (US$) in Micronesia?
Ensure brevity in your answer.  2.11e+08. In the year 1996, what is the difference between the Aid flow from UN agencies (US$) of Middle income and Aid flow from UN agencies (US$) of Sudan?
Make the answer very short. 2.06e+08. In the year 1996, what is the difference between the Aid flow from UN agencies (US$) in Lao PDR and Aid flow from UN agencies (US$) in Micronesia?
Make the answer very short. 8.10e+06. In the year 1996, what is the difference between the Aid flow from UN agencies (US$) of Lao PDR and Aid flow from UN agencies (US$) of Sudan?
Offer a very short reply. 3.61e+06. In the year 1996, what is the difference between the Aid flow from UN agencies (US$) in Micronesia and Aid flow from UN agencies (US$) in Sudan?
Your response must be concise. -4.49e+06. In the year 1997, what is the difference between the Aid flow from UN agencies (US$) in Middle income and Aid flow from UN agencies (US$) in Lao PDR?
Provide a succinct answer. 2.66e+08. In the year 1997, what is the difference between the Aid flow from UN agencies (US$) of Middle income and Aid flow from UN agencies (US$) of Micronesia?
Your answer should be compact. 2.74e+08. In the year 1997, what is the difference between the Aid flow from UN agencies (US$) of Middle income and Aid flow from UN agencies (US$) of Sudan?
Keep it short and to the point. 2.66e+08. In the year 1997, what is the difference between the Aid flow from UN agencies (US$) in Lao PDR and Aid flow from UN agencies (US$) in Micronesia?
Offer a terse response. 7.65e+06. In the year 1997, what is the difference between the Aid flow from UN agencies (US$) of Lao PDR and Aid flow from UN agencies (US$) of Sudan?
Provide a short and direct response. -7.50e+05. In the year 1997, what is the difference between the Aid flow from UN agencies (US$) in Micronesia and Aid flow from UN agencies (US$) in Sudan?
Provide a succinct answer. -8.40e+06. In the year 1998, what is the difference between the Aid flow from UN agencies (US$) of Middle income and Aid flow from UN agencies (US$) of Lao PDR?
Provide a succinct answer. 2.23e+08. In the year 1998, what is the difference between the Aid flow from UN agencies (US$) in Middle income and Aid flow from UN agencies (US$) in Sudan?
Your answer should be compact. 2.21e+08. In the year 1998, what is the difference between the Aid flow from UN agencies (US$) of Lao PDR and Aid flow from UN agencies (US$) of Sudan?
Give a very brief answer. -1.33e+06. In the year 1999, what is the difference between the Aid flow from UN agencies (US$) in Middle income and Aid flow from UN agencies (US$) in Lao PDR?
Offer a very short reply. 1.72e+08. In the year 1999, what is the difference between the Aid flow from UN agencies (US$) of Middle income and Aid flow from UN agencies (US$) of Micronesia?
Your answer should be compact. 1.77e+08. In the year 1999, what is the difference between the Aid flow from UN agencies (US$) of Middle income and Aid flow from UN agencies (US$) of Sudan?
Make the answer very short. 1.67e+08. In the year 1999, what is the difference between the Aid flow from UN agencies (US$) of Lao PDR and Aid flow from UN agencies (US$) of Micronesia?
Keep it short and to the point. 4.19e+06. In the year 1999, what is the difference between the Aid flow from UN agencies (US$) of Lao PDR and Aid flow from UN agencies (US$) of Sudan?
Provide a short and direct response. -5.68e+06. In the year 1999, what is the difference between the Aid flow from UN agencies (US$) of Micronesia and Aid flow from UN agencies (US$) of Sudan?
Make the answer very short. -9.87e+06. In the year 2000, what is the difference between the Aid flow from UN agencies (US$) in Middle income and Aid flow from UN agencies (US$) in Lao PDR?
Ensure brevity in your answer.  1.66e+08. In the year 2000, what is the difference between the Aid flow from UN agencies (US$) in Middle income and Aid flow from UN agencies (US$) in Micronesia?
Keep it short and to the point. 1.68e+08. In the year 2000, what is the difference between the Aid flow from UN agencies (US$) of Middle income and Aid flow from UN agencies (US$) of Sudan?
Your response must be concise. 1.62e+08. In the year 2000, what is the difference between the Aid flow from UN agencies (US$) of Lao PDR and Aid flow from UN agencies (US$) of Micronesia?
Ensure brevity in your answer.  2.65e+06. In the year 2000, what is the difference between the Aid flow from UN agencies (US$) of Lao PDR and Aid flow from UN agencies (US$) of Sudan?
Give a very brief answer. -4.10e+06. In the year 2000, what is the difference between the Aid flow from UN agencies (US$) of Micronesia and Aid flow from UN agencies (US$) of Sudan?
Make the answer very short. -6.75e+06. In the year 2001, what is the difference between the Aid flow from UN agencies (US$) in Middle income and Aid flow from UN agencies (US$) in Lao PDR?
Your answer should be compact. 1.31e+08. In the year 2001, what is the difference between the Aid flow from UN agencies (US$) of Middle income and Aid flow from UN agencies (US$) of Micronesia?
Provide a succinct answer. 1.32e+08. In the year 2001, what is the difference between the Aid flow from UN agencies (US$) of Middle income and Aid flow from UN agencies (US$) of Sudan?
Give a very brief answer. 1.30e+08. In the year 2001, what is the difference between the Aid flow from UN agencies (US$) in Lao PDR and Aid flow from UN agencies (US$) in Micronesia?
Keep it short and to the point. 1.51e+06. In the year 2001, what is the difference between the Aid flow from UN agencies (US$) in Lao PDR and Aid flow from UN agencies (US$) in Sudan?
Your response must be concise. -7.00e+05. In the year 2001, what is the difference between the Aid flow from UN agencies (US$) in Micronesia and Aid flow from UN agencies (US$) in Sudan?
Give a very brief answer. -2.21e+06. In the year 2002, what is the difference between the Aid flow from UN agencies (US$) of Middle income and Aid flow from UN agencies (US$) of Lao PDR?
Make the answer very short. 1.38e+08. In the year 2002, what is the difference between the Aid flow from UN agencies (US$) of Middle income and Aid flow from UN agencies (US$) of Micronesia?
Your answer should be compact. 1.39e+08. In the year 2002, what is the difference between the Aid flow from UN agencies (US$) in Middle income and Aid flow from UN agencies (US$) in Sudan?
Offer a terse response. 1.38e+08. In the year 2002, what is the difference between the Aid flow from UN agencies (US$) of Lao PDR and Aid flow from UN agencies (US$) of Micronesia?
Your response must be concise. 1.10e+06. In the year 2002, what is the difference between the Aid flow from UN agencies (US$) in Lao PDR and Aid flow from UN agencies (US$) in Sudan?
Your answer should be very brief. -8.30e+05. In the year 2002, what is the difference between the Aid flow from UN agencies (US$) in Micronesia and Aid flow from UN agencies (US$) in Sudan?
Ensure brevity in your answer.  -1.93e+06. In the year 2011, what is the difference between the Aid flow from UN agencies (US$) in Middle income and Aid flow from UN agencies (US$) in Lao PDR?
Keep it short and to the point. 1.71e+08. In the year 2011, what is the difference between the Aid flow from UN agencies (US$) of Middle income and Aid flow from UN agencies (US$) of Micronesia?
Keep it short and to the point. 1.75e+08. In the year 2011, what is the difference between the Aid flow from UN agencies (US$) in Middle income and Aid flow from UN agencies (US$) in Sudan?
Make the answer very short. 1.71e+08. In the year 2011, what is the difference between the Aid flow from UN agencies (US$) of Lao PDR and Aid flow from UN agencies (US$) of Micronesia?
Offer a terse response. 3.76e+06. In the year 2011, what is the difference between the Aid flow from UN agencies (US$) of Lao PDR and Aid flow from UN agencies (US$) of Sudan?
Make the answer very short. -7.50e+05. In the year 2011, what is the difference between the Aid flow from UN agencies (US$) in Micronesia and Aid flow from UN agencies (US$) in Sudan?
Your answer should be compact. -4.51e+06. What is the ratio of the Aid flow from UN agencies (US$) in Middle income in 1996 to that in 1997?
Give a very brief answer. 0.77. What is the ratio of the Aid flow from UN agencies (US$) of Lao PDR in 1996 to that in 1997?
Your response must be concise. 1.11. What is the ratio of the Aid flow from UN agencies (US$) of Micronesia in 1996 to that in 1997?
Ensure brevity in your answer.  3.64. What is the ratio of the Aid flow from UN agencies (US$) in Sudan in 1996 to that in 1997?
Ensure brevity in your answer.  0.59. What is the ratio of the Aid flow from UN agencies (US$) in Middle income in 1996 to that in 1998?
Give a very brief answer. 0.93. What is the ratio of the Aid flow from UN agencies (US$) of Lao PDR in 1996 to that in 1998?
Your response must be concise. 1.9. What is the ratio of the Aid flow from UN agencies (US$) in Sudan in 1996 to that in 1998?
Your answer should be compact. 0.85. What is the ratio of the Aid flow from UN agencies (US$) of Middle income in 1996 to that in 1999?
Provide a short and direct response. 1.2. What is the ratio of the Aid flow from UN agencies (US$) of Lao PDR in 1996 to that in 1999?
Your answer should be compact. 1.97. What is the ratio of the Aid flow from UN agencies (US$) in Micronesia in 1996 to that in 1999?
Your answer should be very brief. 2.83. What is the ratio of the Aid flow from UN agencies (US$) of Sudan in 1996 to that in 1999?
Give a very brief answer. 0.5. What is the ratio of the Aid flow from UN agencies (US$) in Middle income in 1996 to that in 2000?
Your response must be concise. 1.25. What is the ratio of the Aid flow from UN agencies (US$) in Lao PDR in 1996 to that in 2000?
Your answer should be compact. 3.08. What is the ratio of the Aid flow from UN agencies (US$) of Sudan in 1996 to that in 2000?
Give a very brief answer. 0.72. What is the ratio of the Aid flow from UN agencies (US$) of Middle income in 1996 to that in 2001?
Ensure brevity in your answer.  1.6. What is the ratio of the Aid flow from UN agencies (US$) of Lao PDR in 1996 to that in 2001?
Provide a short and direct response. 5.66. What is the ratio of the Aid flow from UN agencies (US$) in Sudan in 1996 to that in 2001?
Your response must be concise. 2.25. What is the ratio of the Aid flow from UN agencies (US$) in Middle income in 1996 to that in 2002?
Your answer should be very brief. 1.52. What is the ratio of the Aid flow from UN agencies (US$) in Lao PDR in 1996 to that in 2002?
Your answer should be compact. 7.69. What is the ratio of the Aid flow from UN agencies (US$) of Sudan in 1996 to that in 2002?
Your response must be concise. 2.56. What is the ratio of the Aid flow from UN agencies (US$) of Middle income in 1996 to that in 2011?
Keep it short and to the point. 1.21. What is the ratio of the Aid flow from UN agencies (US$) of Lao PDR in 1996 to that in 2011?
Ensure brevity in your answer.  2.24. What is the ratio of the Aid flow from UN agencies (US$) of Micronesia in 1996 to that in 2011?
Ensure brevity in your answer.  6.38. What is the ratio of the Aid flow from UN agencies (US$) in Sudan in 1996 to that in 2011?
Keep it short and to the point. 1.09. What is the ratio of the Aid flow from UN agencies (US$) in Middle income in 1997 to that in 1998?
Keep it short and to the point. 1.21. What is the ratio of the Aid flow from UN agencies (US$) of Lao PDR in 1997 to that in 1998?
Your response must be concise. 1.72. What is the ratio of the Aid flow from UN agencies (US$) of Sudan in 1997 to that in 1998?
Give a very brief answer. 1.46. What is the ratio of the Aid flow from UN agencies (US$) of Middle income in 1997 to that in 1999?
Provide a succinct answer. 1.55. What is the ratio of the Aid flow from UN agencies (US$) in Lao PDR in 1997 to that in 1999?
Provide a short and direct response. 1.78. What is the ratio of the Aid flow from UN agencies (US$) in Micronesia in 1997 to that in 1999?
Keep it short and to the point. 0.78. What is the ratio of the Aid flow from UN agencies (US$) of Sudan in 1997 to that in 1999?
Keep it short and to the point. 0.85. What is the ratio of the Aid flow from UN agencies (US$) in Middle income in 1997 to that in 2000?
Your response must be concise. 1.63. What is the ratio of the Aid flow from UN agencies (US$) of Lao PDR in 1997 to that in 2000?
Offer a terse response. 2.78. What is the ratio of the Aid flow from UN agencies (US$) of Sudan in 1997 to that in 2000?
Offer a very short reply. 1.24. What is the ratio of the Aid flow from UN agencies (US$) of Middle income in 1997 to that in 2001?
Provide a short and direct response. 2.07. What is the ratio of the Aid flow from UN agencies (US$) in Lao PDR in 1997 to that in 2001?
Provide a short and direct response. 5.12. What is the ratio of the Aid flow from UN agencies (US$) in Micronesia in 1997 to that in 2001?
Provide a succinct answer. 14. What is the ratio of the Aid flow from UN agencies (US$) of Sudan in 1997 to that in 2001?
Keep it short and to the point. 3.85. What is the ratio of the Aid flow from UN agencies (US$) in Middle income in 1997 to that in 2002?
Provide a succinct answer. 1.96. What is the ratio of the Aid flow from UN agencies (US$) of Lao PDR in 1997 to that in 2002?
Provide a short and direct response. 6.96. What is the ratio of the Aid flow from UN agencies (US$) in Micronesia in 1997 to that in 2002?
Offer a terse response. 7. What is the ratio of the Aid flow from UN agencies (US$) of Sudan in 1997 to that in 2002?
Provide a succinct answer. 4.38. What is the ratio of the Aid flow from UN agencies (US$) in Middle income in 1997 to that in 2011?
Provide a short and direct response. 1.56. What is the ratio of the Aid flow from UN agencies (US$) of Lao PDR in 1997 to that in 2011?
Your answer should be compact. 2.03. What is the ratio of the Aid flow from UN agencies (US$) of Sudan in 1997 to that in 2011?
Your answer should be very brief. 1.86. What is the ratio of the Aid flow from UN agencies (US$) in Middle income in 1998 to that in 1999?
Offer a terse response. 1.29. What is the ratio of the Aid flow from UN agencies (US$) of Lao PDR in 1998 to that in 1999?
Provide a short and direct response. 1.04. What is the ratio of the Aid flow from UN agencies (US$) of Sudan in 1998 to that in 1999?
Your answer should be compact. 0.58. What is the ratio of the Aid flow from UN agencies (US$) in Middle income in 1998 to that in 2000?
Provide a short and direct response. 1.35. What is the ratio of the Aid flow from UN agencies (US$) of Lao PDR in 1998 to that in 2000?
Your answer should be very brief. 1.62. What is the ratio of the Aid flow from UN agencies (US$) of Sudan in 1998 to that in 2000?
Your response must be concise. 0.85. What is the ratio of the Aid flow from UN agencies (US$) of Middle income in 1998 to that in 2001?
Make the answer very short. 1.72. What is the ratio of the Aid flow from UN agencies (US$) in Lao PDR in 1998 to that in 2001?
Your response must be concise. 2.98. What is the ratio of the Aid flow from UN agencies (US$) of Sudan in 1998 to that in 2001?
Your response must be concise. 2.64. What is the ratio of the Aid flow from UN agencies (US$) of Middle income in 1998 to that in 2002?
Your answer should be compact. 1.63. What is the ratio of the Aid flow from UN agencies (US$) in Lao PDR in 1998 to that in 2002?
Offer a terse response. 4.04. What is the ratio of the Aid flow from UN agencies (US$) in Sudan in 1998 to that in 2002?
Make the answer very short. 3.01. What is the ratio of the Aid flow from UN agencies (US$) of Middle income in 1998 to that in 2011?
Offer a very short reply. 1.3. What is the ratio of the Aid flow from UN agencies (US$) of Lao PDR in 1998 to that in 2011?
Offer a terse response. 1.18. What is the ratio of the Aid flow from UN agencies (US$) of Sudan in 1998 to that in 2011?
Offer a very short reply. 1.28. What is the ratio of the Aid flow from UN agencies (US$) of Middle income in 1999 to that in 2000?
Your response must be concise. 1.05. What is the ratio of the Aid flow from UN agencies (US$) of Lao PDR in 1999 to that in 2000?
Offer a terse response. 1.56. What is the ratio of the Aid flow from UN agencies (US$) of Micronesia in 1999 to that in 2000?
Give a very brief answer. 1.2. What is the ratio of the Aid flow from UN agencies (US$) of Sudan in 1999 to that in 2000?
Offer a very short reply. 1.46. What is the ratio of the Aid flow from UN agencies (US$) in Middle income in 1999 to that in 2001?
Give a very brief answer. 1.34. What is the ratio of the Aid flow from UN agencies (US$) in Lao PDR in 1999 to that in 2001?
Make the answer very short. 2.88. What is the ratio of the Aid flow from UN agencies (US$) of Sudan in 1999 to that in 2001?
Keep it short and to the point. 4.53. What is the ratio of the Aid flow from UN agencies (US$) of Middle income in 1999 to that in 2002?
Make the answer very short. 1.27. What is the ratio of the Aid flow from UN agencies (US$) of Lao PDR in 1999 to that in 2002?
Keep it short and to the point. 3.9. What is the ratio of the Aid flow from UN agencies (US$) of Micronesia in 1999 to that in 2002?
Keep it short and to the point. 9. What is the ratio of the Aid flow from UN agencies (US$) in Sudan in 1999 to that in 2002?
Provide a short and direct response. 5.15. What is the ratio of the Aid flow from UN agencies (US$) of Middle income in 1999 to that in 2011?
Provide a succinct answer. 1.01. What is the ratio of the Aid flow from UN agencies (US$) of Lao PDR in 1999 to that in 2011?
Keep it short and to the point. 1.14. What is the ratio of the Aid flow from UN agencies (US$) in Micronesia in 1999 to that in 2011?
Provide a succinct answer. 2.25. What is the ratio of the Aid flow from UN agencies (US$) of Sudan in 1999 to that in 2011?
Your response must be concise. 2.19. What is the ratio of the Aid flow from UN agencies (US$) of Middle income in 2000 to that in 2001?
Give a very brief answer. 1.27. What is the ratio of the Aid flow from UN agencies (US$) in Lao PDR in 2000 to that in 2001?
Offer a terse response. 1.84. What is the ratio of the Aid flow from UN agencies (US$) in Micronesia in 2000 to that in 2001?
Provide a succinct answer. 15. What is the ratio of the Aid flow from UN agencies (US$) in Sudan in 2000 to that in 2001?
Offer a very short reply. 3.11. What is the ratio of the Aid flow from UN agencies (US$) in Middle income in 2000 to that in 2002?
Keep it short and to the point. 1.21. What is the ratio of the Aid flow from UN agencies (US$) of Lao PDR in 2000 to that in 2002?
Give a very brief answer. 2.5. What is the ratio of the Aid flow from UN agencies (US$) in Micronesia in 2000 to that in 2002?
Ensure brevity in your answer.  7.5. What is the ratio of the Aid flow from UN agencies (US$) in Sudan in 2000 to that in 2002?
Offer a very short reply. 3.54. What is the ratio of the Aid flow from UN agencies (US$) of Middle income in 2000 to that in 2011?
Make the answer very short. 0.96. What is the ratio of the Aid flow from UN agencies (US$) in Lao PDR in 2000 to that in 2011?
Your answer should be very brief. 0.73. What is the ratio of the Aid flow from UN agencies (US$) in Micronesia in 2000 to that in 2011?
Provide a succinct answer. 1.88. What is the ratio of the Aid flow from UN agencies (US$) in Sudan in 2000 to that in 2011?
Offer a very short reply. 1.5. What is the ratio of the Aid flow from UN agencies (US$) in Middle income in 2001 to that in 2002?
Give a very brief answer. 0.95. What is the ratio of the Aid flow from UN agencies (US$) in Lao PDR in 2001 to that in 2002?
Your answer should be very brief. 1.36. What is the ratio of the Aid flow from UN agencies (US$) in Sudan in 2001 to that in 2002?
Provide a succinct answer. 1.14. What is the ratio of the Aid flow from UN agencies (US$) of Middle income in 2001 to that in 2011?
Your answer should be compact. 0.75. What is the ratio of the Aid flow from UN agencies (US$) in Lao PDR in 2001 to that in 2011?
Ensure brevity in your answer.  0.4. What is the ratio of the Aid flow from UN agencies (US$) of Micronesia in 2001 to that in 2011?
Offer a terse response. 0.12. What is the ratio of the Aid flow from UN agencies (US$) of Sudan in 2001 to that in 2011?
Provide a short and direct response. 0.48. What is the ratio of the Aid flow from UN agencies (US$) in Middle income in 2002 to that in 2011?
Your answer should be compact. 0.8. What is the ratio of the Aid flow from UN agencies (US$) in Lao PDR in 2002 to that in 2011?
Provide a succinct answer. 0.29. What is the ratio of the Aid flow from UN agencies (US$) in Sudan in 2002 to that in 2011?
Provide a succinct answer. 0.42. What is the difference between the highest and the second highest Aid flow from UN agencies (US$) of Middle income?
Give a very brief answer. 4.69e+07. What is the difference between the highest and the second highest Aid flow from UN agencies (US$) in Lao PDR?
Your answer should be compact. 8.20e+05. What is the difference between the highest and the second highest Aid flow from UN agencies (US$) of Sudan?
Provide a short and direct response. 1.51e+06. What is the difference between the highest and the lowest Aid flow from UN agencies (US$) of Middle income?
Keep it short and to the point. 1.42e+08. What is the difference between the highest and the lowest Aid flow from UN agencies (US$) in Lao PDR?
Your answer should be compact. 7.49e+06. What is the difference between the highest and the lowest Aid flow from UN agencies (US$) of Micronesia?
Provide a short and direct response. 5.10e+05. What is the difference between the highest and the lowest Aid flow from UN agencies (US$) in Sudan?
Provide a short and direct response. 8.10e+06. 